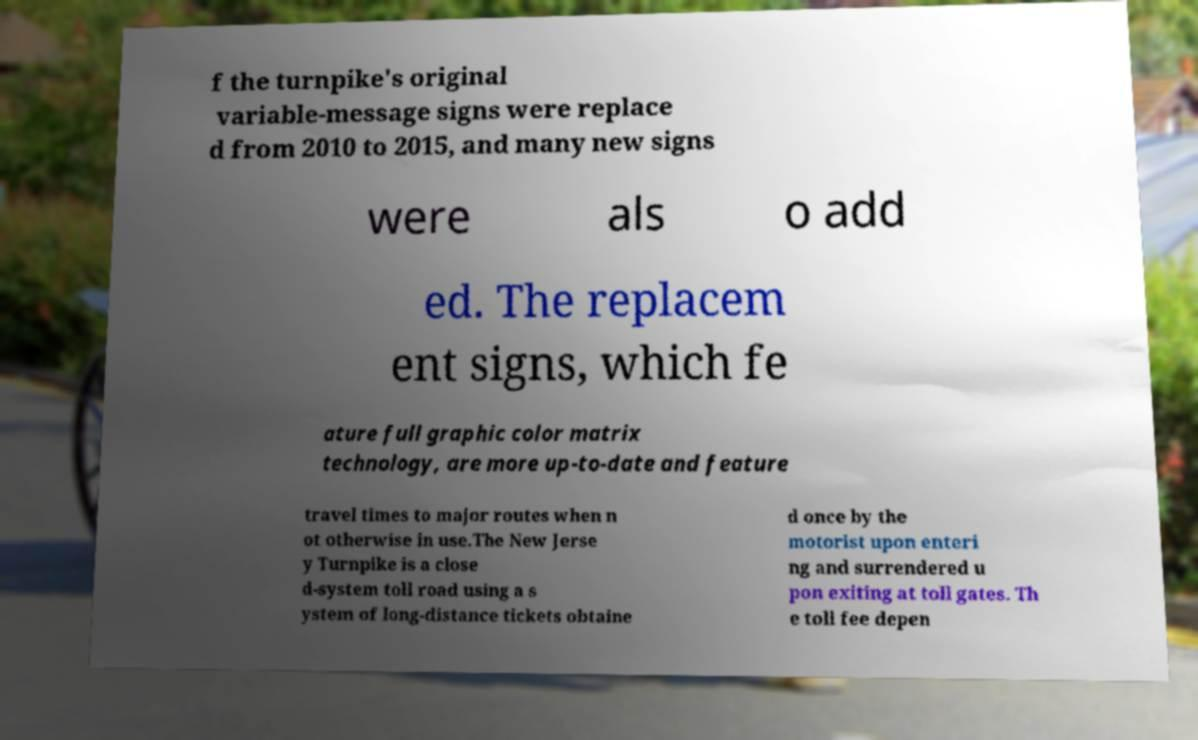What messages or text are displayed in this image? I need them in a readable, typed format. f the turnpike's original variable-message signs were replace d from 2010 to 2015, and many new signs were als o add ed. The replacem ent signs, which fe ature full graphic color matrix technology, are more up-to-date and feature travel times to major routes when n ot otherwise in use.The New Jerse y Turnpike is a close d-system toll road using a s ystem of long-distance tickets obtaine d once by the motorist upon enteri ng and surrendered u pon exiting at toll gates. Th e toll fee depen 